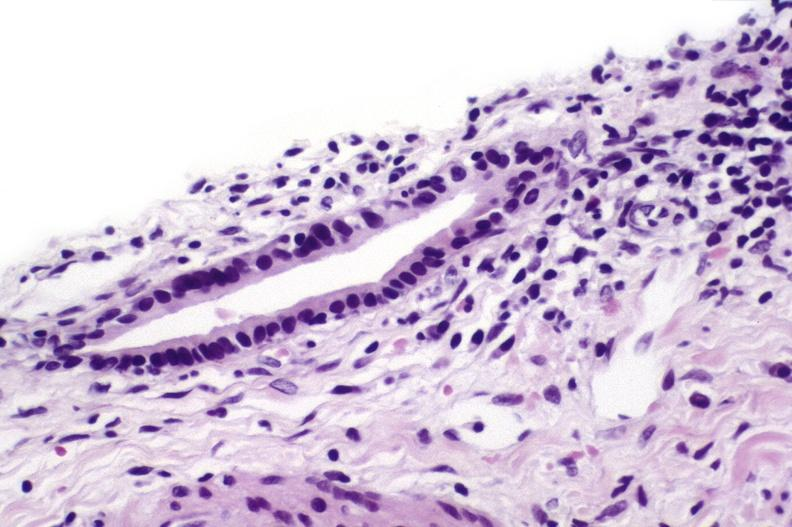does this image show sarcoid?
Answer the question using a single word or phrase. Yes 